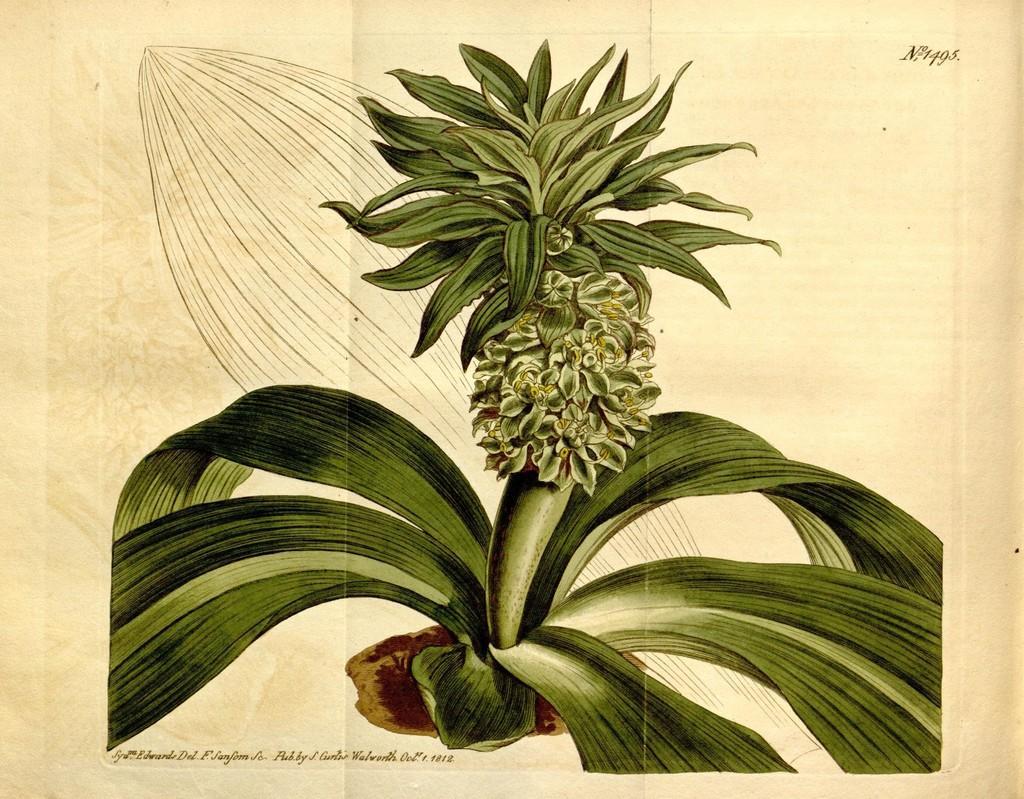Can you describe this image briefly? In the picture there is an image of a plant. 